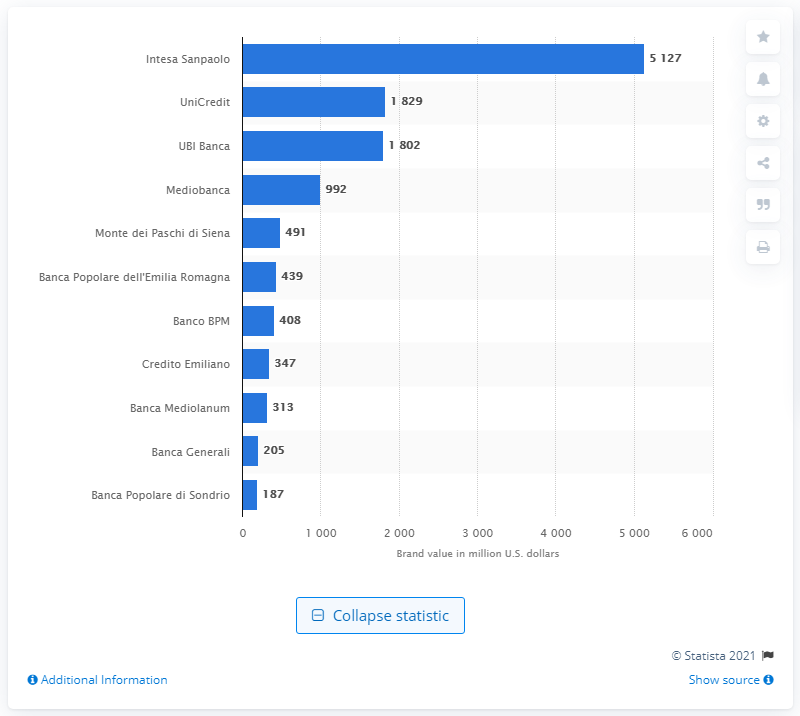Draw attention to some important aspects in this diagram. In 2018, the brand value of Intesa Sanpaolo was approximately 5,127. In 2018, Intesa Sanpaolo was ranked as the leading Italian bank in a global brand value ranking. 